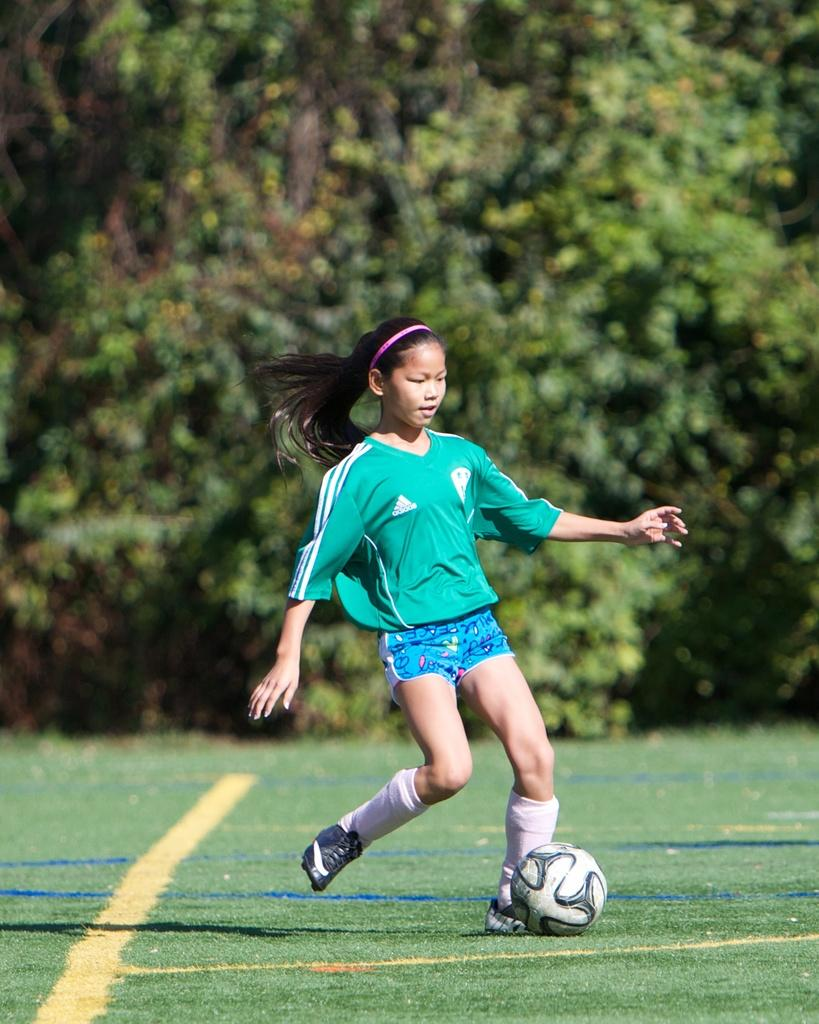What can be seen in the background of the image? There are trees in the background of the image. What is the girl in the image doing? The girl is playing football in the image. Where is the girl playing football? The girl is on a ground. What accessory is the girl wearing in her hair? The girl is wearing a pink hairband. What type of toothbrush is the girl using while playing football in the image? There is no toothbrush present in the image; the girl is playing football without any toothbrush. 